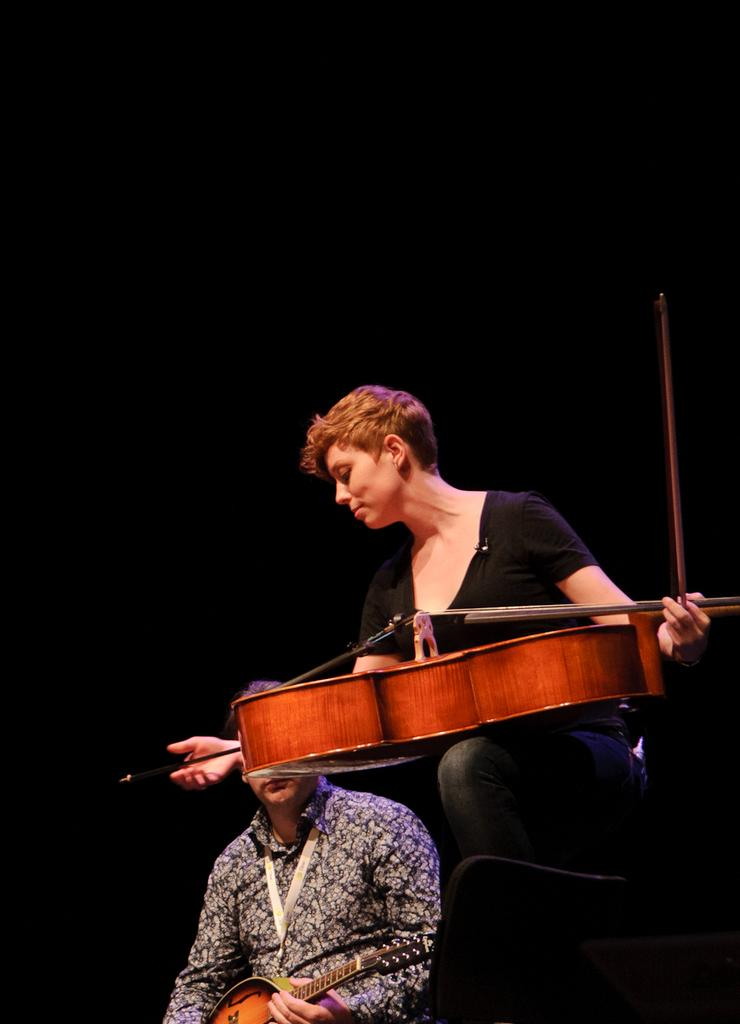What is the overall color scheme of the image? The background of the image is dark. What is the main subject of the image? There is a person holding a guitar in the image. Are there any other musicians in the image? Yes, there is another person holding a musical instrument in the image. What type of garden can be seen in the background of the image? There is no garden present in the background of the image; it is dark. What kind of soup is being prepared by the person holding the guitar? There is no soup or cooking activity present in the image; the person is holding a guitar. 